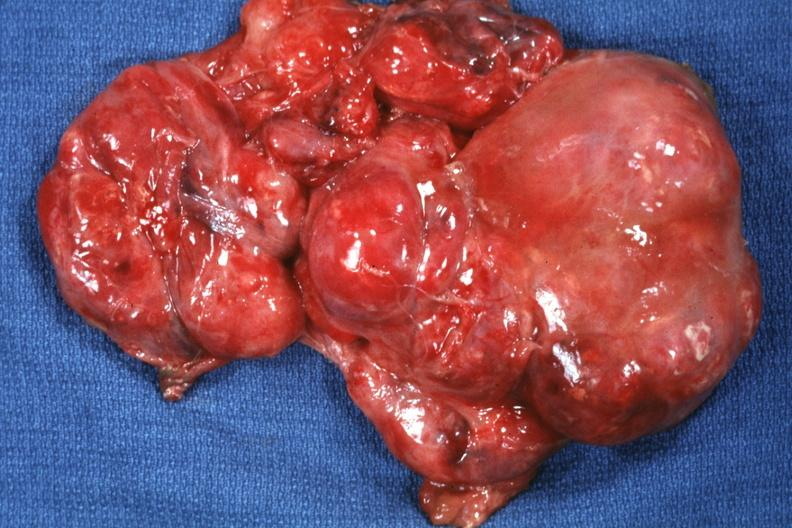what does this image show?
Answer the question using a single word or phrase. Excised tumor 